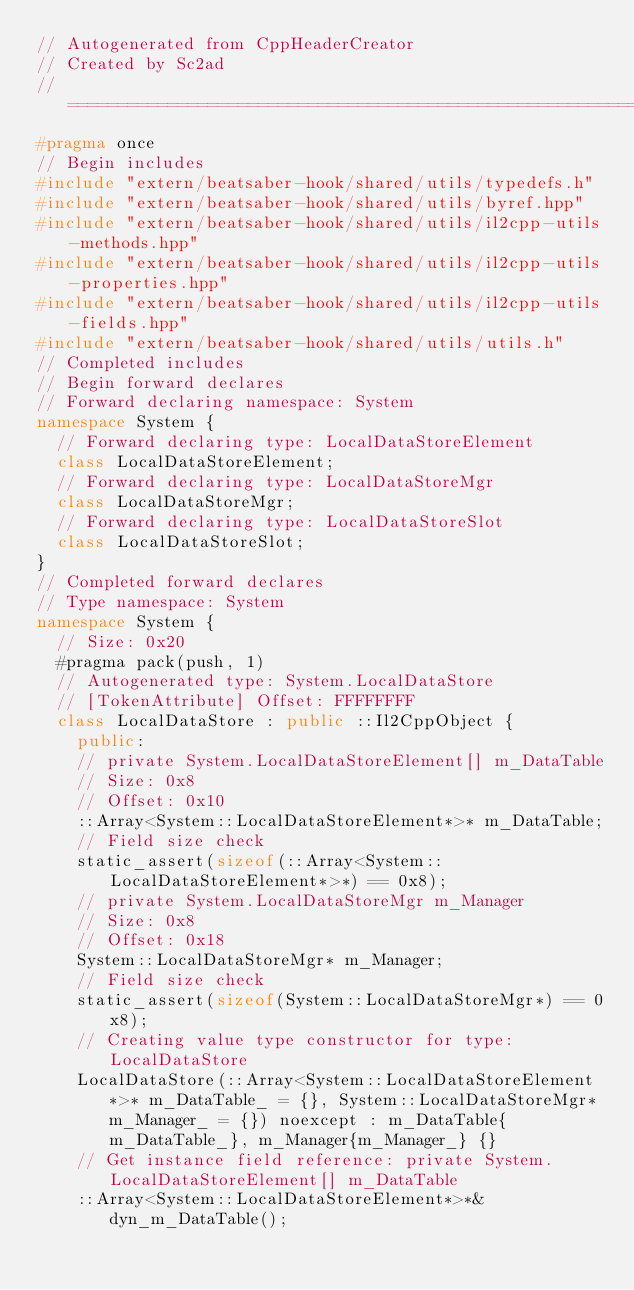Convert code to text. <code><loc_0><loc_0><loc_500><loc_500><_C++_>// Autogenerated from CppHeaderCreator
// Created by Sc2ad
// =========================================================================
#pragma once
// Begin includes
#include "extern/beatsaber-hook/shared/utils/typedefs.h"
#include "extern/beatsaber-hook/shared/utils/byref.hpp"
#include "extern/beatsaber-hook/shared/utils/il2cpp-utils-methods.hpp"
#include "extern/beatsaber-hook/shared/utils/il2cpp-utils-properties.hpp"
#include "extern/beatsaber-hook/shared/utils/il2cpp-utils-fields.hpp"
#include "extern/beatsaber-hook/shared/utils/utils.h"
// Completed includes
// Begin forward declares
// Forward declaring namespace: System
namespace System {
  // Forward declaring type: LocalDataStoreElement
  class LocalDataStoreElement;
  // Forward declaring type: LocalDataStoreMgr
  class LocalDataStoreMgr;
  // Forward declaring type: LocalDataStoreSlot
  class LocalDataStoreSlot;
}
// Completed forward declares
// Type namespace: System
namespace System {
  // Size: 0x20
  #pragma pack(push, 1)
  // Autogenerated type: System.LocalDataStore
  // [TokenAttribute] Offset: FFFFFFFF
  class LocalDataStore : public ::Il2CppObject {
    public:
    // private System.LocalDataStoreElement[] m_DataTable
    // Size: 0x8
    // Offset: 0x10
    ::Array<System::LocalDataStoreElement*>* m_DataTable;
    // Field size check
    static_assert(sizeof(::Array<System::LocalDataStoreElement*>*) == 0x8);
    // private System.LocalDataStoreMgr m_Manager
    // Size: 0x8
    // Offset: 0x18
    System::LocalDataStoreMgr* m_Manager;
    // Field size check
    static_assert(sizeof(System::LocalDataStoreMgr*) == 0x8);
    // Creating value type constructor for type: LocalDataStore
    LocalDataStore(::Array<System::LocalDataStoreElement*>* m_DataTable_ = {}, System::LocalDataStoreMgr* m_Manager_ = {}) noexcept : m_DataTable{m_DataTable_}, m_Manager{m_Manager_} {}
    // Get instance field reference: private System.LocalDataStoreElement[] m_DataTable
    ::Array<System::LocalDataStoreElement*>*& dyn_m_DataTable();</code> 